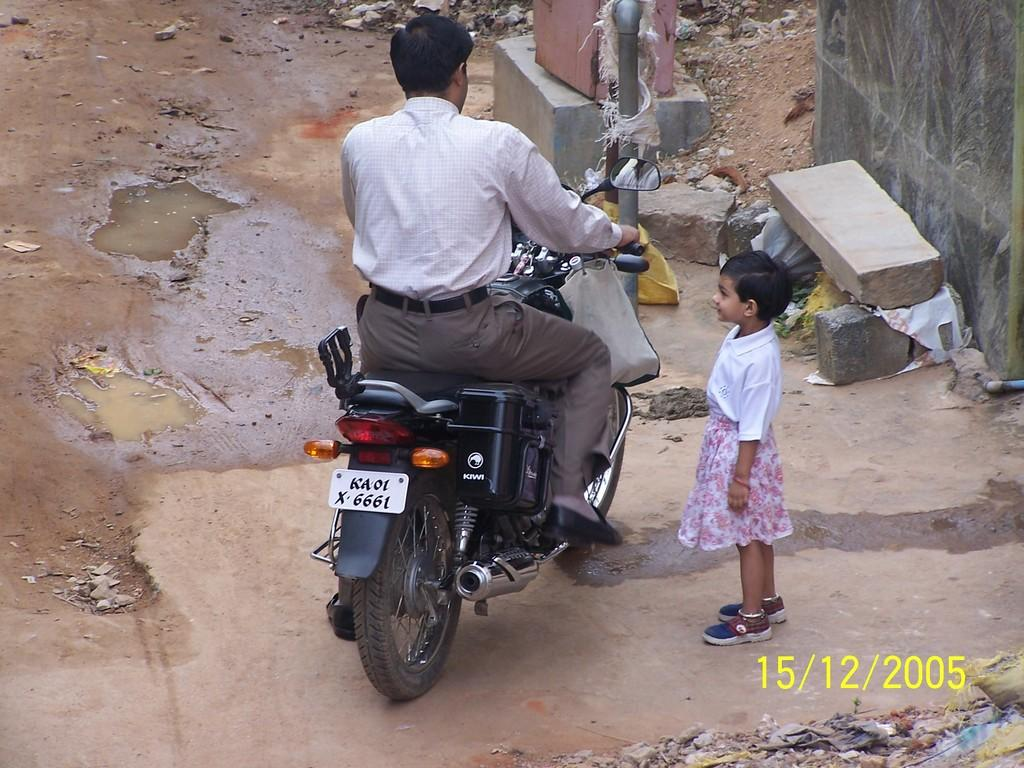What is the man in the image doing? The man is sitting on a bike in the image. Who is with the man in the image? There is a girl standing beside the man in the image. Can you tell me the date written on the image? The date "15/12/2005" is written on the image. Where is the faucet located in the image? There is no faucet present in the image. What color are the man's toes in the image? The image does not show the man's toes, so we cannot determine their color. 